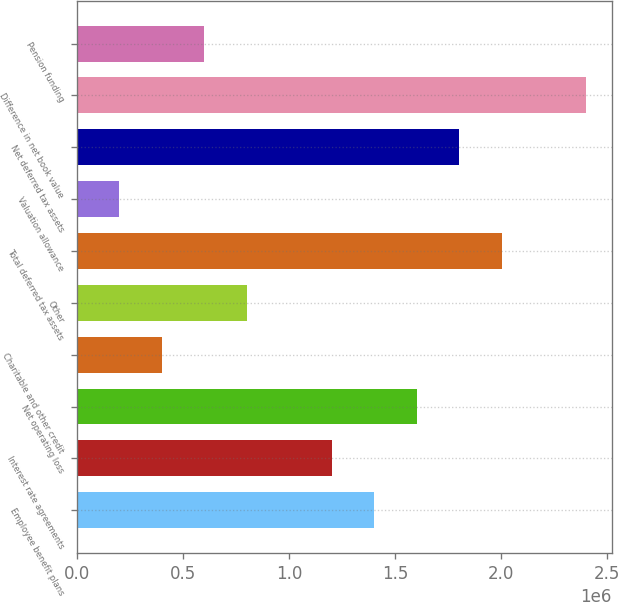Convert chart to OTSL. <chart><loc_0><loc_0><loc_500><loc_500><bar_chart><fcel>Employee benefit plans<fcel>Interest rate agreements<fcel>Net operating loss<fcel>Charitable and other credit<fcel>Other<fcel>Total deferred tax assets<fcel>Valuation allowance<fcel>Net deferred tax assets<fcel>Difference in net book value<fcel>Pension funding<nl><fcel>1.401e+06<fcel>1.20091e+06<fcel>1.60108e+06<fcel>400579<fcel>800746<fcel>2.00125e+06<fcel>200496<fcel>1.80116e+06<fcel>2.40141e+06<fcel>600662<nl></chart> 